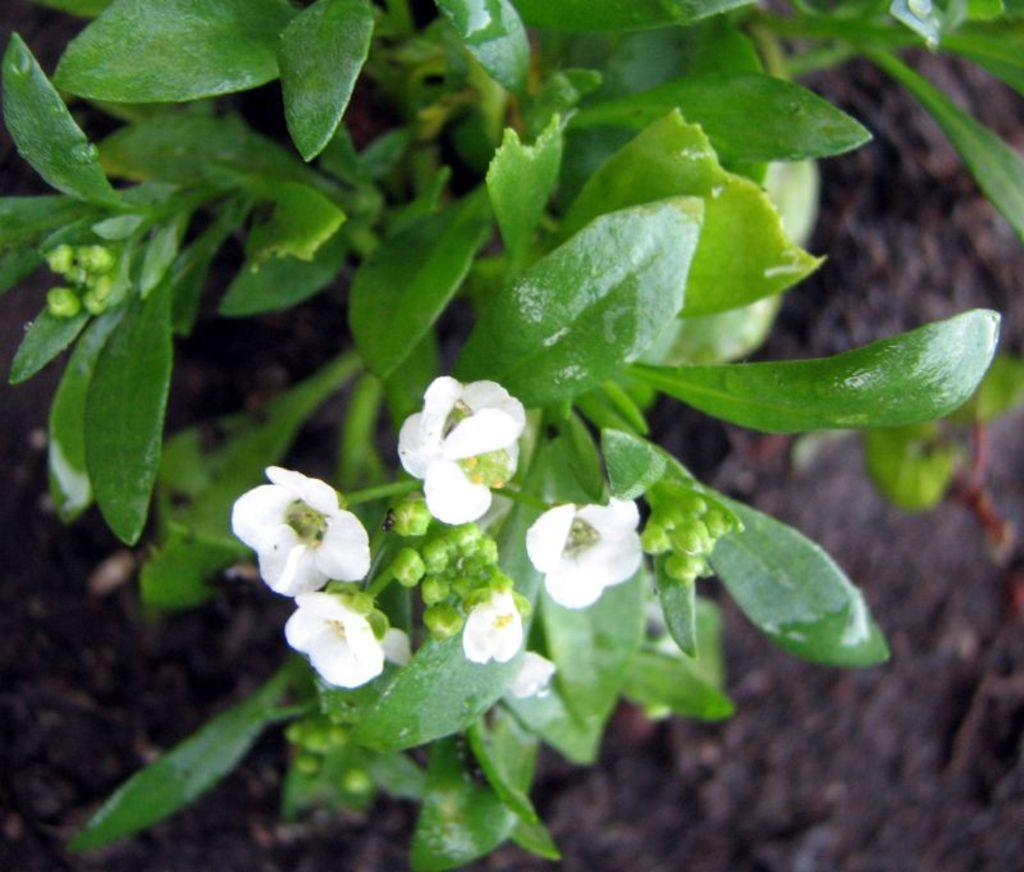What type of living organisms can be seen in the image? Plants can be seen in the image. What color are the flowers on the plants? The flowers on the plants are white. What is the ground like under the plants? There is a muddy path under the plants. What type of kettle can be seen in the image? There is no kettle present in the image. What color is the silverware in the image? There is no silverware present in the image. 